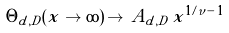<formula> <loc_0><loc_0><loc_500><loc_500>\Theta _ { d , D } ( x \to \infty ) \, \to \, A _ { d , D } \, x ^ { 1 / \nu \, - \, 1 }</formula> 